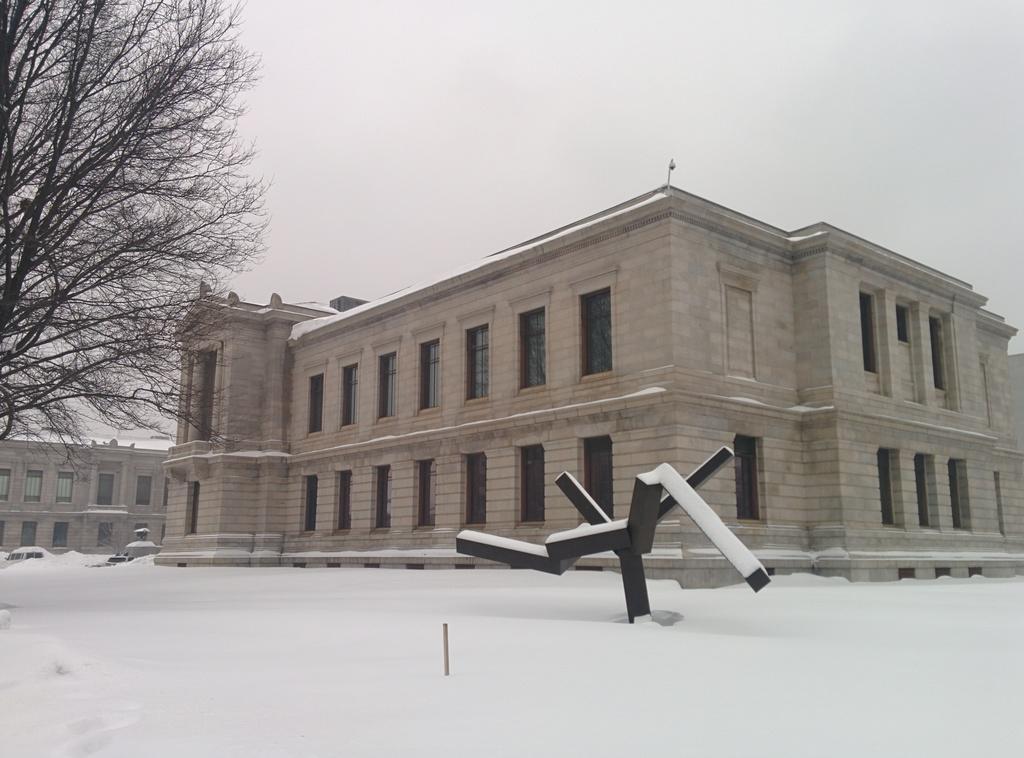Please provide a concise description of this image. In the image there is a lot of snow in the foreground, behind the snow there are two buildings and on the left side there is a tree. 